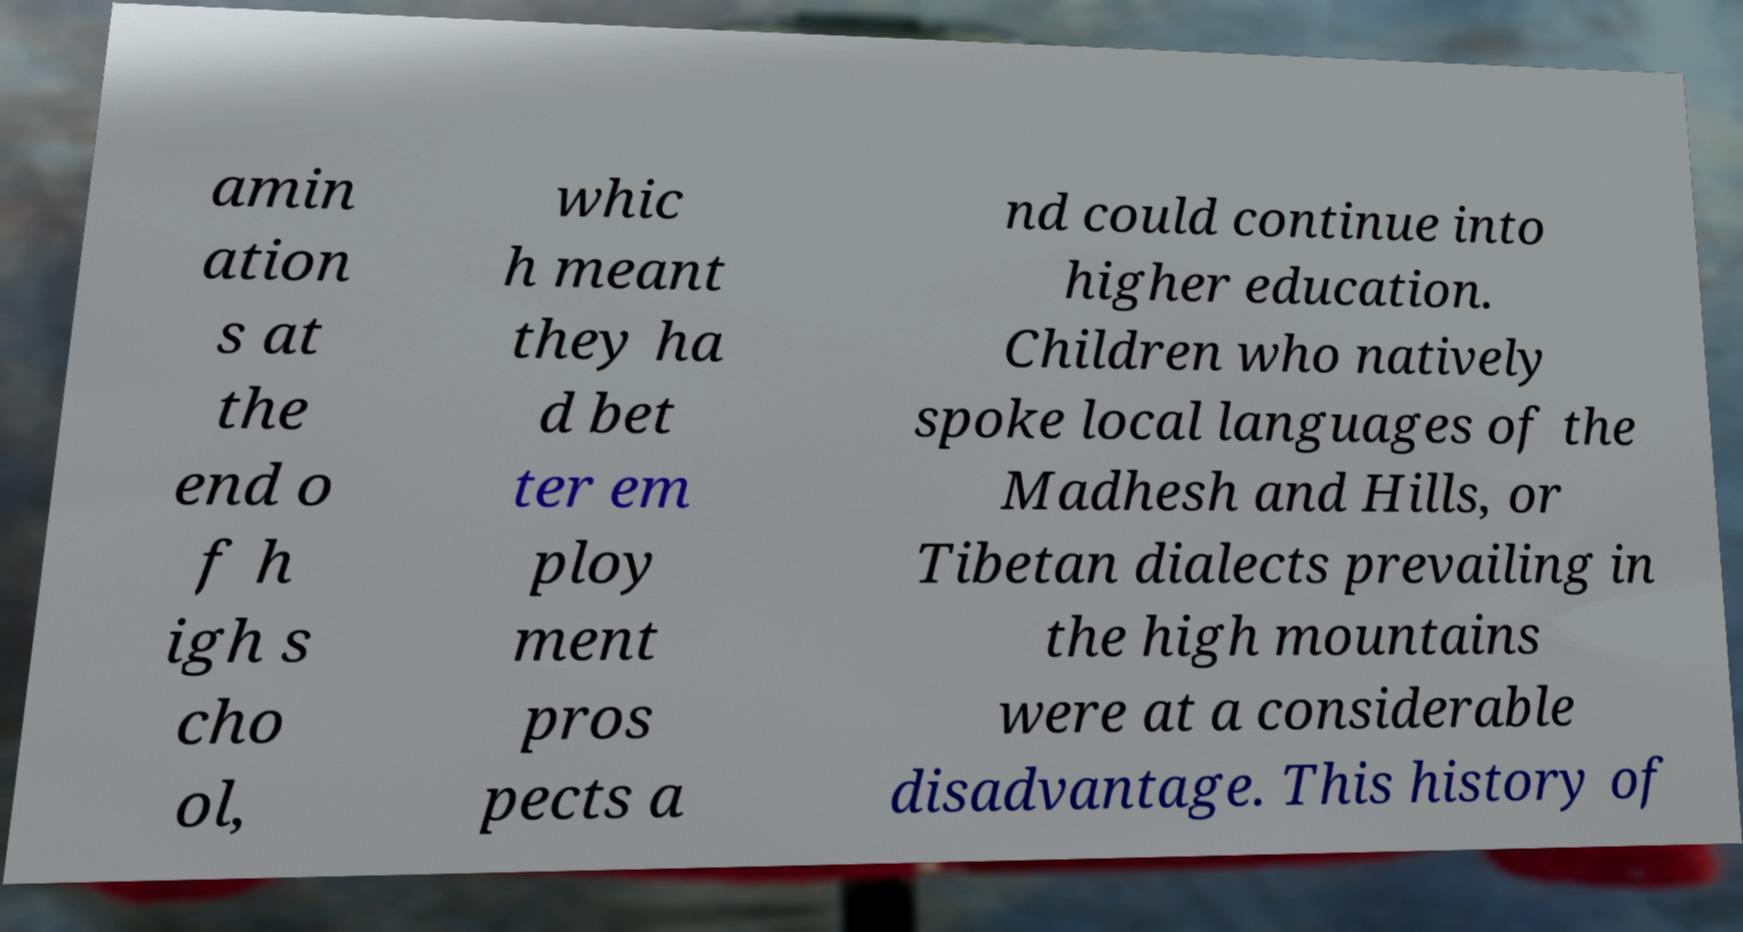Could you assist in decoding the text presented in this image and type it out clearly? amin ation s at the end o f h igh s cho ol, whic h meant they ha d bet ter em ploy ment pros pects a nd could continue into higher education. Children who natively spoke local languages of the Madhesh and Hills, or Tibetan dialects prevailing in the high mountains were at a considerable disadvantage. This history of 